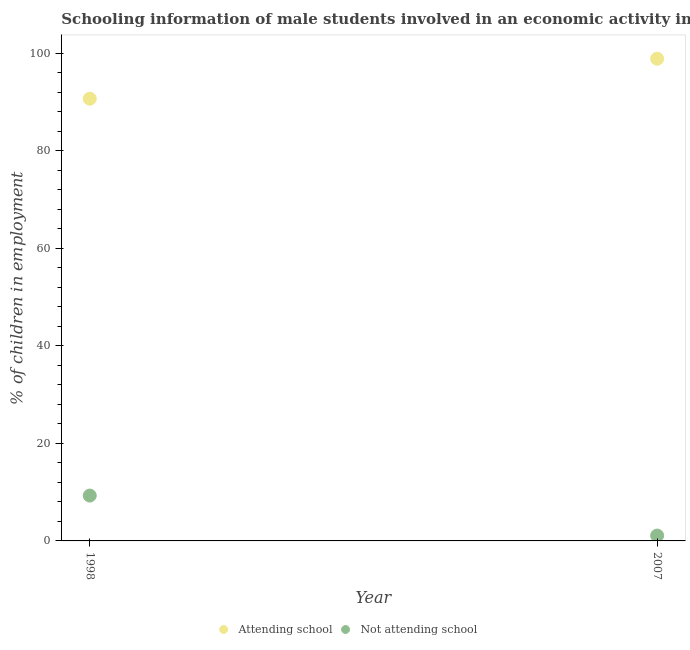Is the number of dotlines equal to the number of legend labels?
Ensure brevity in your answer.  Yes. What is the percentage of employed males who are attending school in 1998?
Your answer should be very brief. 90.7. Across all years, what is the maximum percentage of employed males who are attending school?
Offer a terse response. 98.9. Across all years, what is the minimum percentage of employed males who are not attending school?
Your answer should be very brief. 1.1. In which year was the percentage of employed males who are not attending school maximum?
Your answer should be very brief. 1998. In which year was the percentage of employed males who are not attending school minimum?
Offer a terse response. 2007. What is the total percentage of employed males who are attending school in the graph?
Keep it short and to the point. 189.6. What is the difference between the percentage of employed males who are attending school in 1998 and that in 2007?
Your response must be concise. -8.2. What is the difference between the percentage of employed males who are attending school in 2007 and the percentage of employed males who are not attending school in 1998?
Your answer should be compact. 89.6. In the year 1998, what is the difference between the percentage of employed males who are not attending school and percentage of employed males who are attending school?
Keep it short and to the point. -81.4. What is the ratio of the percentage of employed males who are not attending school in 1998 to that in 2007?
Ensure brevity in your answer.  8.45. Is the percentage of employed males who are not attending school in 1998 less than that in 2007?
Your answer should be very brief. No. In how many years, is the percentage of employed males who are attending school greater than the average percentage of employed males who are attending school taken over all years?
Your response must be concise. 1. Is the percentage of employed males who are not attending school strictly greater than the percentage of employed males who are attending school over the years?
Make the answer very short. No. Is the percentage of employed males who are attending school strictly less than the percentage of employed males who are not attending school over the years?
Offer a very short reply. No. How many years are there in the graph?
Keep it short and to the point. 2. Does the graph contain any zero values?
Offer a terse response. No. How many legend labels are there?
Your answer should be compact. 2. How are the legend labels stacked?
Provide a succinct answer. Horizontal. What is the title of the graph?
Provide a succinct answer. Schooling information of male students involved in an economic activity in Kyrgyz Republic. Does "International Visitors" appear as one of the legend labels in the graph?
Your answer should be very brief. No. What is the label or title of the Y-axis?
Your answer should be compact. % of children in employment. What is the % of children in employment of Attending school in 1998?
Offer a terse response. 90.7. What is the % of children in employment of Not attending school in 1998?
Provide a short and direct response. 9.3. What is the % of children in employment of Attending school in 2007?
Keep it short and to the point. 98.9. Across all years, what is the maximum % of children in employment of Attending school?
Your answer should be very brief. 98.9. Across all years, what is the minimum % of children in employment of Attending school?
Provide a succinct answer. 90.7. What is the total % of children in employment in Attending school in the graph?
Provide a short and direct response. 189.6. What is the total % of children in employment in Not attending school in the graph?
Offer a very short reply. 10.4. What is the difference between the % of children in employment of Attending school in 1998 and that in 2007?
Provide a short and direct response. -8.2. What is the difference between the % of children in employment in Not attending school in 1998 and that in 2007?
Make the answer very short. 8.2. What is the difference between the % of children in employment in Attending school in 1998 and the % of children in employment in Not attending school in 2007?
Ensure brevity in your answer.  89.6. What is the average % of children in employment of Attending school per year?
Offer a terse response. 94.8. In the year 1998, what is the difference between the % of children in employment in Attending school and % of children in employment in Not attending school?
Your response must be concise. 81.4. In the year 2007, what is the difference between the % of children in employment in Attending school and % of children in employment in Not attending school?
Provide a succinct answer. 97.8. What is the ratio of the % of children in employment of Attending school in 1998 to that in 2007?
Your response must be concise. 0.92. What is the ratio of the % of children in employment of Not attending school in 1998 to that in 2007?
Make the answer very short. 8.45. What is the difference between the highest and the second highest % of children in employment in Not attending school?
Provide a succinct answer. 8.2. What is the difference between the highest and the lowest % of children in employment of Attending school?
Provide a succinct answer. 8.2. What is the difference between the highest and the lowest % of children in employment in Not attending school?
Provide a succinct answer. 8.2. 